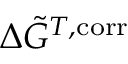Convert formula to latex. <formula><loc_0><loc_0><loc_500><loc_500>\Delta \tilde { G } ^ { T , c o r r }</formula> 